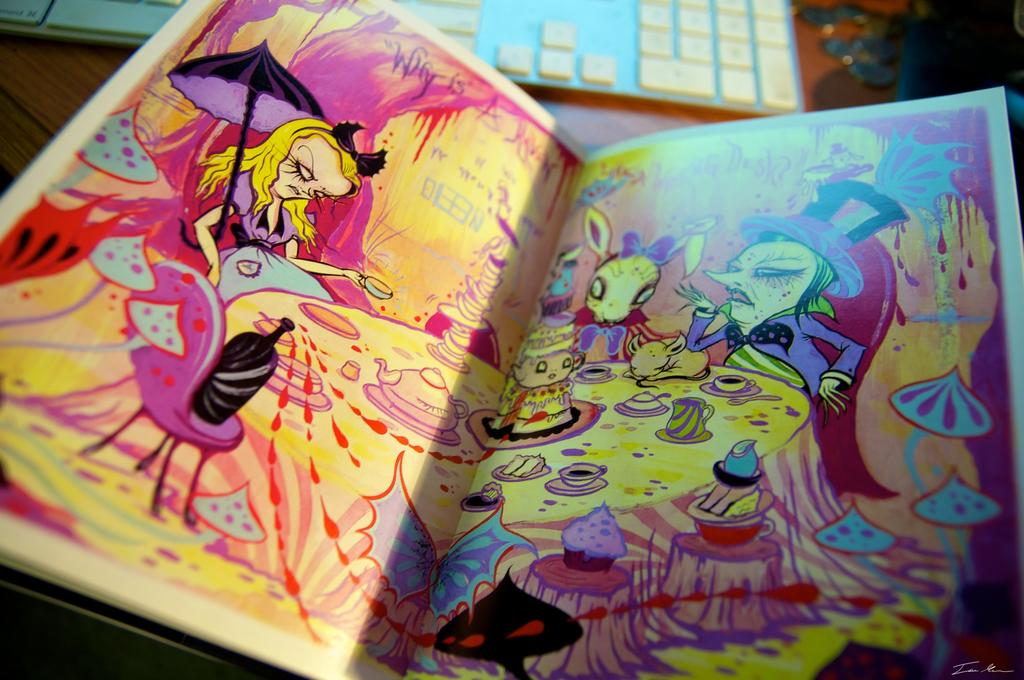What is the main subject of the image? The main subject of the image is an open book. What type of content is in the book? The book contains cartoons. What object is in front of the book? There is a keyboard in front of the book. What type of crime is being committed in the image? There is no crime being committed in the image; it features an open book with cartoons and a keyboard. What shape is the keyboard in the image? The shape of the keyboard is not mentioned in the facts provided, but it is likely rectangular or similar to a standard keyboard. 